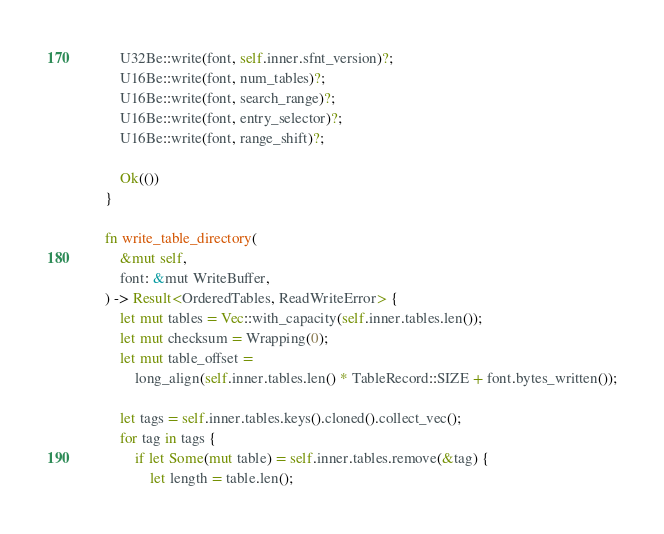Convert code to text. <code><loc_0><loc_0><loc_500><loc_500><_Rust_>
        U32Be::write(font, self.inner.sfnt_version)?;
        U16Be::write(font, num_tables)?;
        U16Be::write(font, search_range)?;
        U16Be::write(font, entry_selector)?;
        U16Be::write(font, range_shift)?;

        Ok(())
    }

    fn write_table_directory(
        &mut self,
        font: &mut WriteBuffer,
    ) -> Result<OrderedTables, ReadWriteError> {
        let mut tables = Vec::with_capacity(self.inner.tables.len());
        let mut checksum = Wrapping(0);
        let mut table_offset =
            long_align(self.inner.tables.len() * TableRecord::SIZE + font.bytes_written());

        let tags = self.inner.tables.keys().cloned().collect_vec();
        for tag in tags {
            if let Some(mut table) = self.inner.tables.remove(&tag) {
                let length = table.len();</code> 